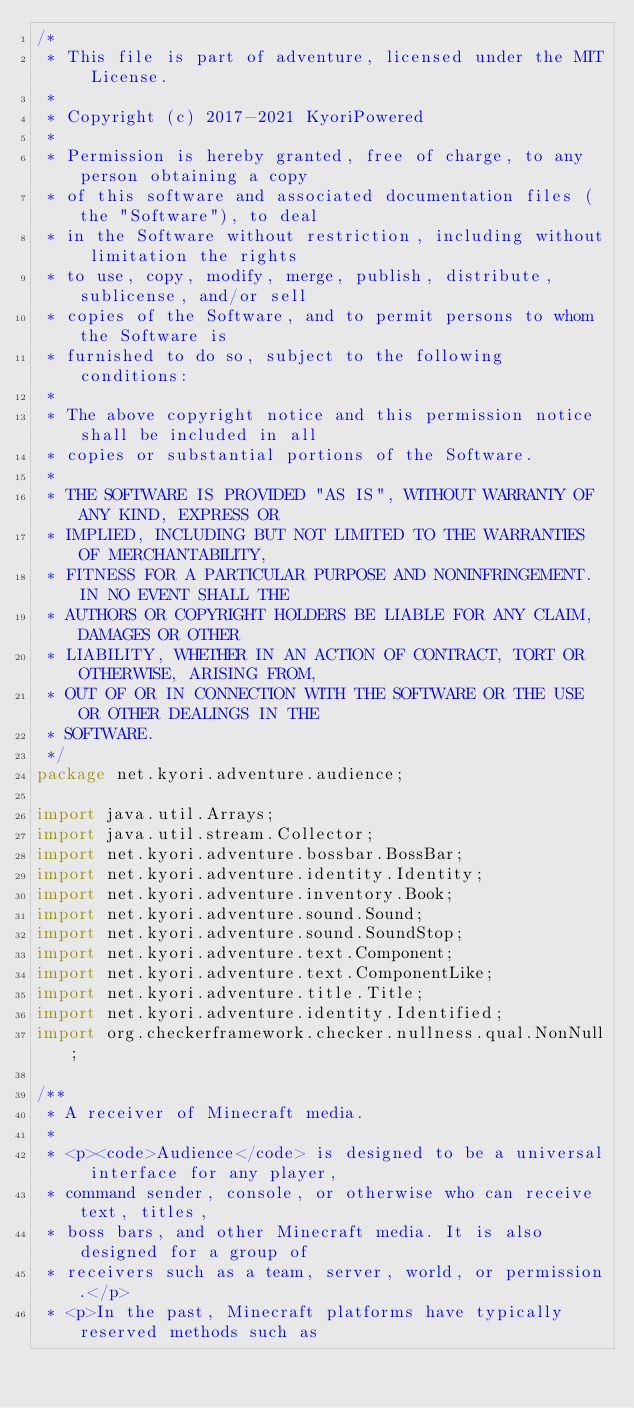<code> <loc_0><loc_0><loc_500><loc_500><_Java_>/*
 * This file is part of adventure, licensed under the MIT License.
 *
 * Copyright (c) 2017-2021 KyoriPowered
 *
 * Permission is hereby granted, free of charge, to any person obtaining a copy
 * of this software and associated documentation files (the "Software"), to deal
 * in the Software without restriction, including without limitation the rights
 * to use, copy, modify, merge, publish, distribute, sublicense, and/or sell
 * copies of the Software, and to permit persons to whom the Software is
 * furnished to do so, subject to the following conditions:
 *
 * The above copyright notice and this permission notice shall be included in all
 * copies or substantial portions of the Software.
 *
 * THE SOFTWARE IS PROVIDED "AS IS", WITHOUT WARRANTY OF ANY KIND, EXPRESS OR
 * IMPLIED, INCLUDING BUT NOT LIMITED TO THE WARRANTIES OF MERCHANTABILITY,
 * FITNESS FOR A PARTICULAR PURPOSE AND NONINFRINGEMENT. IN NO EVENT SHALL THE
 * AUTHORS OR COPYRIGHT HOLDERS BE LIABLE FOR ANY CLAIM, DAMAGES OR OTHER
 * LIABILITY, WHETHER IN AN ACTION OF CONTRACT, TORT OR OTHERWISE, ARISING FROM,
 * OUT OF OR IN CONNECTION WITH THE SOFTWARE OR THE USE OR OTHER DEALINGS IN THE
 * SOFTWARE.
 */
package net.kyori.adventure.audience;

import java.util.Arrays;
import java.util.stream.Collector;
import net.kyori.adventure.bossbar.BossBar;
import net.kyori.adventure.identity.Identity;
import net.kyori.adventure.inventory.Book;
import net.kyori.adventure.sound.Sound;
import net.kyori.adventure.sound.SoundStop;
import net.kyori.adventure.text.Component;
import net.kyori.adventure.text.ComponentLike;
import net.kyori.adventure.title.Title;
import net.kyori.adventure.identity.Identified;
import org.checkerframework.checker.nullness.qual.NonNull;

/**
 * A receiver of Minecraft media.
 *
 * <p><code>Audience</code> is designed to be a universal interface for any player,
 * command sender, console, or otherwise who can receive text, titles,
 * boss bars, and other Minecraft media. It is also designed for a group of
 * receivers such as a team, server, world, or permission.</p>
 * <p>In the past, Minecraft platforms have typically reserved methods such as</code> 